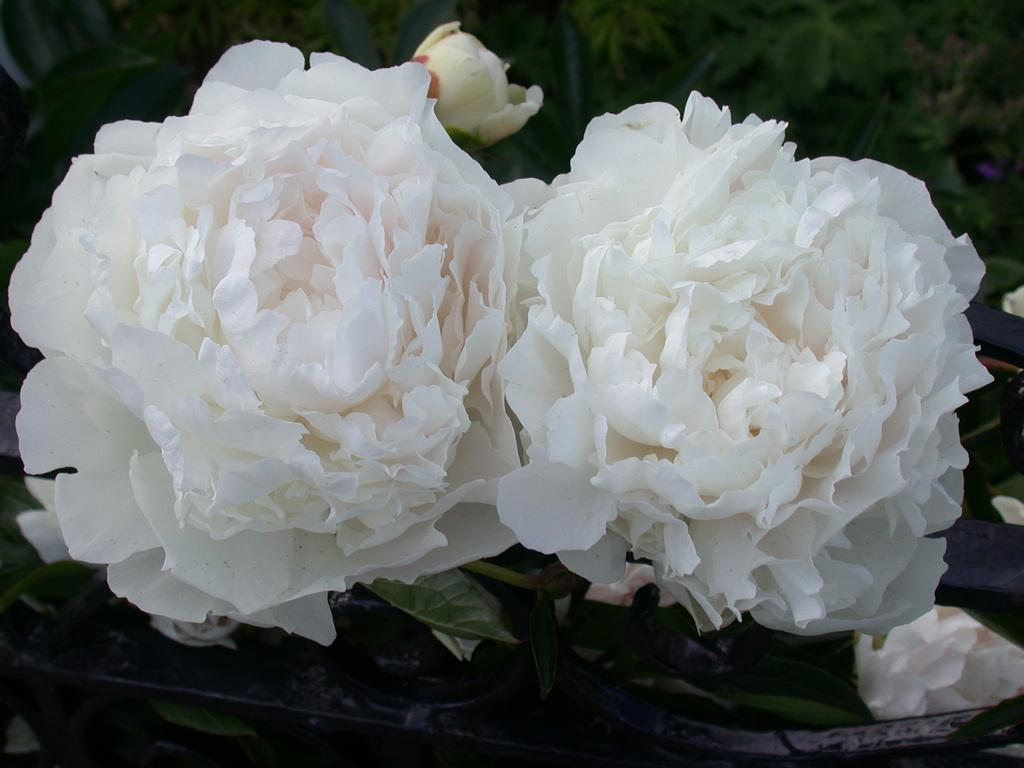What type of living organisms can be seen in the image? There are flowers in the image. What is the color of the background in the image? The background of the image is dark. How does the boy in the image use humor to entertain the flowers? There is no boy present in the image, and therefore no such interaction can be observed. 